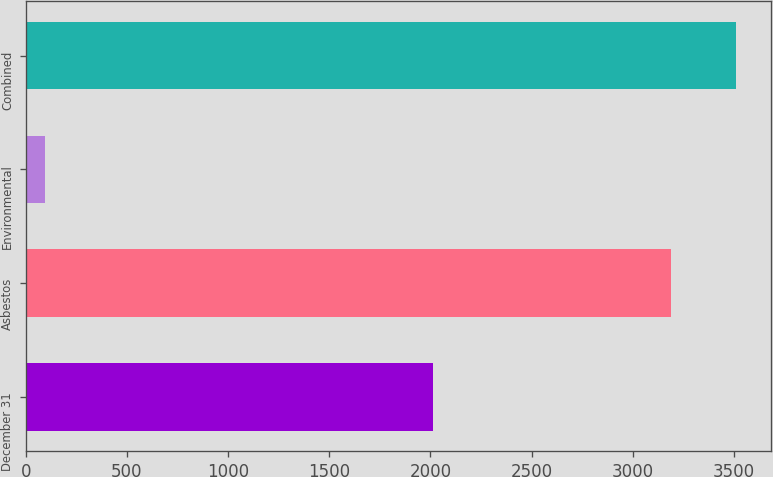Convert chart. <chart><loc_0><loc_0><loc_500><loc_500><bar_chart><fcel>December 31<fcel>Asbestos<fcel>Environmental<fcel>Combined<nl><fcel>2013<fcel>3190<fcel>94<fcel>3509<nl></chart> 